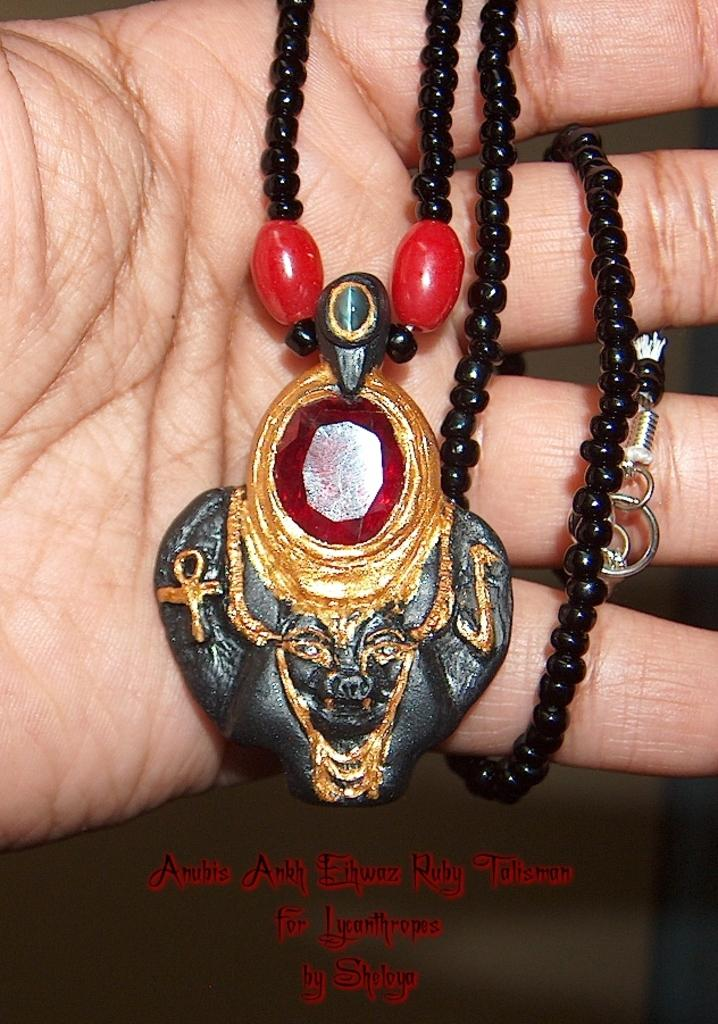What part of a person's body is visible in the image? There is a person's hand in the image. What object is connected to the hand in the image? There is a chain in the image. What is attached to the end of the chain in the image? There is a locket in the image. What type of pail is being used by the person's grandmother in the image? There is no pail or grandmother present in the image. 